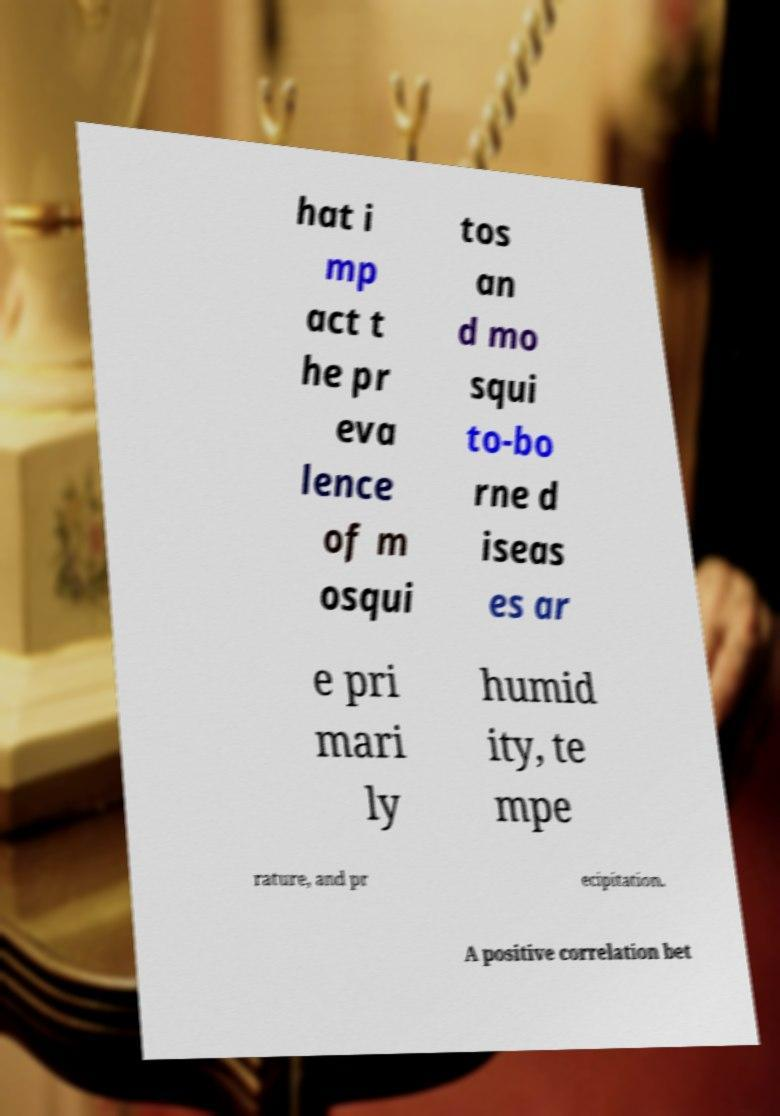What messages or text are displayed in this image? I need them in a readable, typed format. hat i mp act t he pr eva lence of m osqui tos an d mo squi to-bo rne d iseas es ar e pri mari ly humid ity, te mpe rature, and pr ecipitation. A positive correlation bet 